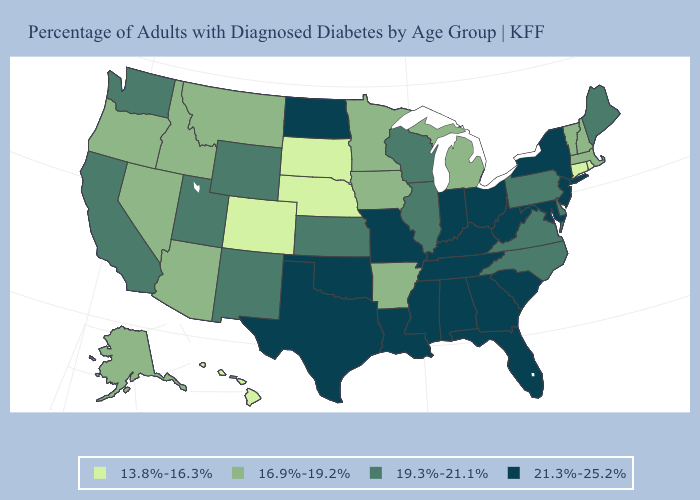Which states hav the highest value in the West?
Quick response, please. California, New Mexico, Utah, Washington, Wyoming. Does Massachusetts have the highest value in the USA?
Keep it brief. No. What is the value of Indiana?
Quick response, please. 21.3%-25.2%. What is the value of Arkansas?
Quick response, please. 16.9%-19.2%. Among the states that border Michigan , does Wisconsin have the lowest value?
Keep it brief. Yes. What is the highest value in states that border Idaho?
Give a very brief answer. 19.3%-21.1%. Name the states that have a value in the range 19.3%-21.1%?
Quick response, please. California, Delaware, Illinois, Kansas, Maine, New Mexico, North Carolina, Pennsylvania, Utah, Virginia, Washington, Wisconsin, Wyoming. What is the value of Alabama?
Answer briefly. 21.3%-25.2%. Name the states that have a value in the range 13.8%-16.3%?
Be succinct. Colorado, Connecticut, Hawaii, Nebraska, Rhode Island, South Dakota. What is the value of Hawaii?
Be succinct. 13.8%-16.3%. Is the legend a continuous bar?
Quick response, please. No. Which states have the lowest value in the Northeast?
Keep it brief. Connecticut, Rhode Island. Which states hav the highest value in the West?
Be succinct. California, New Mexico, Utah, Washington, Wyoming. What is the value of West Virginia?
Answer briefly. 21.3%-25.2%. Does New Jersey have the lowest value in the Northeast?
Concise answer only. No. 